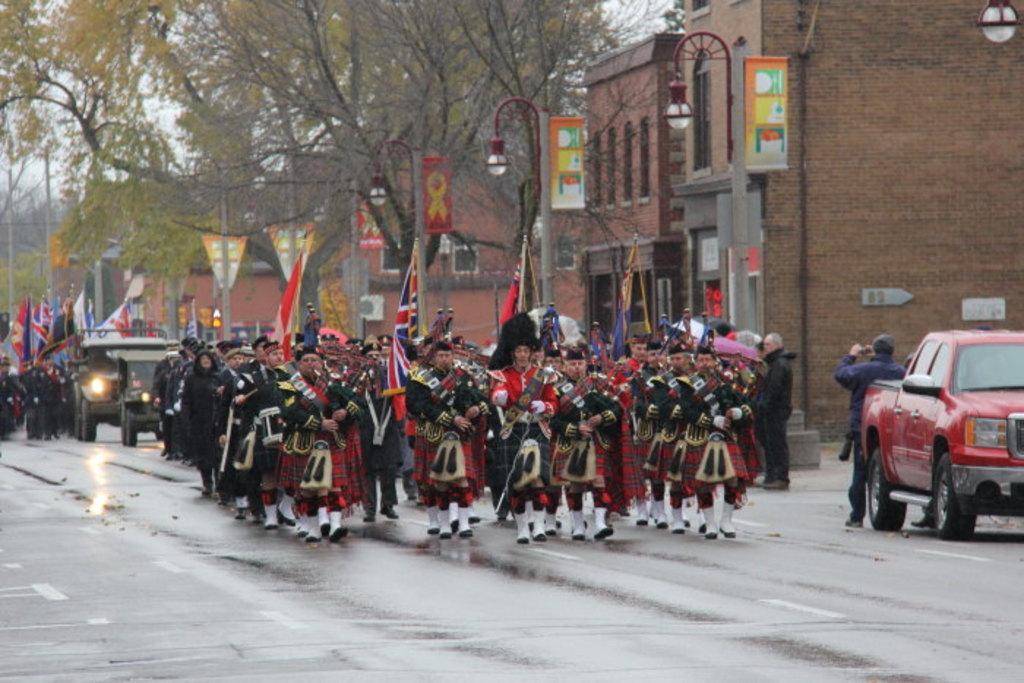Can you describe this image briefly? In this image we can see people wearing uniforms and marching on the road. They are playing musical instruments and holding flags. We can see vehicles. The man standing on the right is holding a camera. In the background there are boards, poles, lights, trees, buildings and sky. 